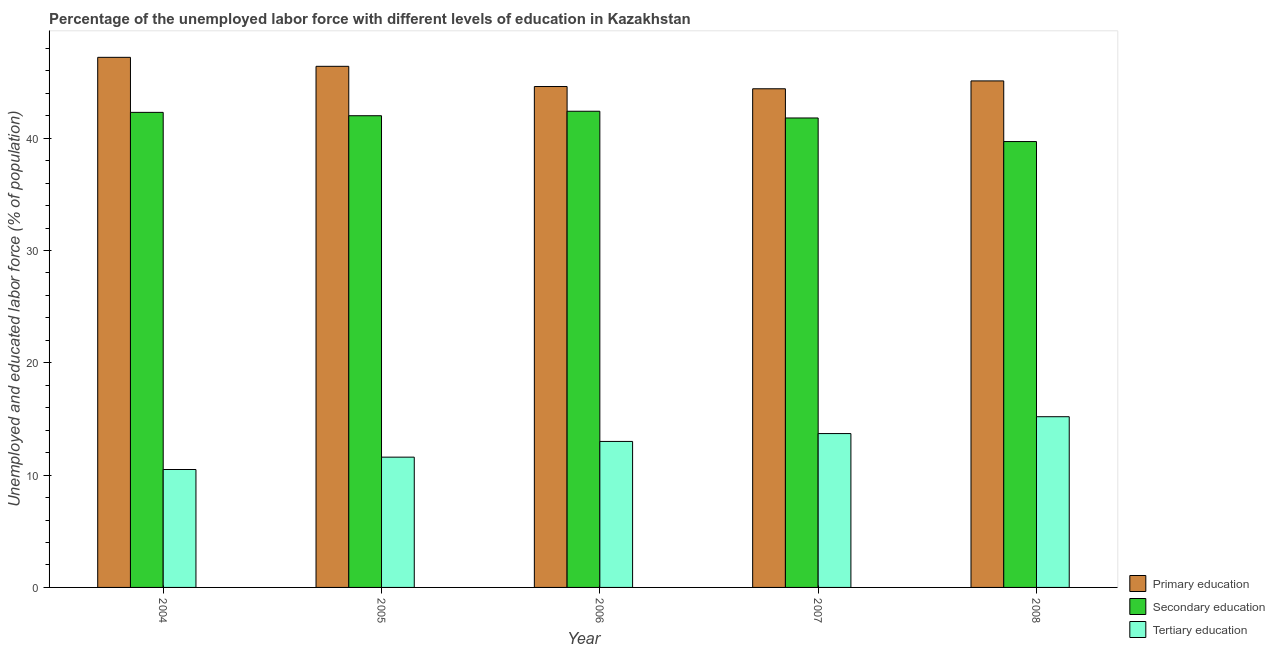Are the number of bars per tick equal to the number of legend labels?
Your answer should be very brief. Yes. How many bars are there on the 1st tick from the left?
Ensure brevity in your answer.  3. How many bars are there on the 5th tick from the right?
Ensure brevity in your answer.  3. What is the label of the 5th group of bars from the left?
Your response must be concise. 2008. What is the percentage of labor force who received primary education in 2005?
Offer a very short reply. 46.4. Across all years, what is the maximum percentage of labor force who received tertiary education?
Make the answer very short. 15.2. Across all years, what is the minimum percentage of labor force who received primary education?
Provide a succinct answer. 44.4. In which year was the percentage of labor force who received primary education minimum?
Your response must be concise. 2007. What is the total percentage of labor force who received tertiary education in the graph?
Make the answer very short. 64. What is the difference between the percentage of labor force who received secondary education in 2006 and that in 2007?
Provide a succinct answer. 0.6. What is the difference between the percentage of labor force who received secondary education in 2007 and the percentage of labor force who received primary education in 2008?
Offer a terse response. 2.1. What is the average percentage of labor force who received tertiary education per year?
Your answer should be compact. 12.8. In the year 2007, what is the difference between the percentage of labor force who received tertiary education and percentage of labor force who received primary education?
Your response must be concise. 0. What is the ratio of the percentage of labor force who received tertiary education in 2006 to that in 2008?
Provide a short and direct response. 0.86. Is the difference between the percentage of labor force who received primary education in 2005 and 2007 greater than the difference between the percentage of labor force who received secondary education in 2005 and 2007?
Your answer should be compact. No. What is the difference between the highest and the second highest percentage of labor force who received secondary education?
Give a very brief answer. 0.1. What is the difference between the highest and the lowest percentage of labor force who received primary education?
Offer a very short reply. 2.8. In how many years, is the percentage of labor force who received secondary education greater than the average percentage of labor force who received secondary education taken over all years?
Provide a succinct answer. 4. What does the 1st bar from the right in 2005 represents?
Your answer should be very brief. Tertiary education. Is it the case that in every year, the sum of the percentage of labor force who received primary education and percentage of labor force who received secondary education is greater than the percentage of labor force who received tertiary education?
Provide a succinct answer. Yes. Are all the bars in the graph horizontal?
Your response must be concise. No. What is the difference between two consecutive major ticks on the Y-axis?
Give a very brief answer. 10. Does the graph contain any zero values?
Your response must be concise. No. Does the graph contain grids?
Offer a terse response. No. What is the title of the graph?
Provide a succinct answer. Percentage of the unemployed labor force with different levels of education in Kazakhstan. Does "Private sector" appear as one of the legend labels in the graph?
Make the answer very short. No. What is the label or title of the Y-axis?
Your answer should be compact. Unemployed and educated labor force (% of population). What is the Unemployed and educated labor force (% of population) in Primary education in 2004?
Offer a very short reply. 47.2. What is the Unemployed and educated labor force (% of population) of Secondary education in 2004?
Ensure brevity in your answer.  42.3. What is the Unemployed and educated labor force (% of population) of Tertiary education in 2004?
Your answer should be compact. 10.5. What is the Unemployed and educated labor force (% of population) of Primary education in 2005?
Provide a succinct answer. 46.4. What is the Unemployed and educated labor force (% of population) of Tertiary education in 2005?
Your response must be concise. 11.6. What is the Unemployed and educated labor force (% of population) of Primary education in 2006?
Make the answer very short. 44.6. What is the Unemployed and educated labor force (% of population) in Secondary education in 2006?
Your response must be concise. 42.4. What is the Unemployed and educated labor force (% of population) of Primary education in 2007?
Offer a very short reply. 44.4. What is the Unemployed and educated labor force (% of population) in Secondary education in 2007?
Provide a succinct answer. 41.8. What is the Unemployed and educated labor force (% of population) in Tertiary education in 2007?
Give a very brief answer. 13.7. What is the Unemployed and educated labor force (% of population) in Primary education in 2008?
Give a very brief answer. 45.1. What is the Unemployed and educated labor force (% of population) of Secondary education in 2008?
Your response must be concise. 39.7. What is the Unemployed and educated labor force (% of population) of Tertiary education in 2008?
Your response must be concise. 15.2. Across all years, what is the maximum Unemployed and educated labor force (% of population) in Primary education?
Ensure brevity in your answer.  47.2. Across all years, what is the maximum Unemployed and educated labor force (% of population) in Secondary education?
Offer a terse response. 42.4. Across all years, what is the maximum Unemployed and educated labor force (% of population) in Tertiary education?
Your response must be concise. 15.2. Across all years, what is the minimum Unemployed and educated labor force (% of population) of Primary education?
Your answer should be very brief. 44.4. Across all years, what is the minimum Unemployed and educated labor force (% of population) in Secondary education?
Your answer should be compact. 39.7. Across all years, what is the minimum Unemployed and educated labor force (% of population) in Tertiary education?
Give a very brief answer. 10.5. What is the total Unemployed and educated labor force (% of population) of Primary education in the graph?
Offer a terse response. 227.7. What is the total Unemployed and educated labor force (% of population) in Secondary education in the graph?
Offer a terse response. 208.2. What is the difference between the Unemployed and educated labor force (% of population) of Secondary education in 2004 and that in 2006?
Provide a short and direct response. -0.1. What is the difference between the Unemployed and educated labor force (% of population) in Tertiary education in 2004 and that in 2007?
Your answer should be compact. -3.2. What is the difference between the Unemployed and educated labor force (% of population) of Primary education in 2004 and that in 2008?
Your response must be concise. 2.1. What is the difference between the Unemployed and educated labor force (% of population) in Secondary education in 2005 and that in 2006?
Keep it short and to the point. -0.4. What is the difference between the Unemployed and educated labor force (% of population) of Tertiary education in 2005 and that in 2006?
Ensure brevity in your answer.  -1.4. What is the difference between the Unemployed and educated labor force (% of population) of Secondary education in 2005 and that in 2007?
Provide a succinct answer. 0.2. What is the difference between the Unemployed and educated labor force (% of population) of Tertiary education in 2005 and that in 2007?
Make the answer very short. -2.1. What is the difference between the Unemployed and educated labor force (% of population) in Primary education in 2005 and that in 2008?
Give a very brief answer. 1.3. What is the difference between the Unemployed and educated labor force (% of population) of Tertiary education in 2005 and that in 2008?
Offer a very short reply. -3.6. What is the difference between the Unemployed and educated labor force (% of population) in Primary education in 2006 and that in 2008?
Your answer should be very brief. -0.5. What is the difference between the Unemployed and educated labor force (% of population) in Secondary education in 2006 and that in 2008?
Give a very brief answer. 2.7. What is the difference between the Unemployed and educated labor force (% of population) in Tertiary education in 2007 and that in 2008?
Keep it short and to the point. -1.5. What is the difference between the Unemployed and educated labor force (% of population) in Primary education in 2004 and the Unemployed and educated labor force (% of population) in Secondary education in 2005?
Ensure brevity in your answer.  5.2. What is the difference between the Unemployed and educated labor force (% of population) of Primary education in 2004 and the Unemployed and educated labor force (% of population) of Tertiary education in 2005?
Make the answer very short. 35.6. What is the difference between the Unemployed and educated labor force (% of population) of Secondary education in 2004 and the Unemployed and educated labor force (% of population) of Tertiary education in 2005?
Give a very brief answer. 30.7. What is the difference between the Unemployed and educated labor force (% of population) of Primary education in 2004 and the Unemployed and educated labor force (% of population) of Tertiary education in 2006?
Provide a short and direct response. 34.2. What is the difference between the Unemployed and educated labor force (% of population) of Secondary education in 2004 and the Unemployed and educated labor force (% of population) of Tertiary education in 2006?
Make the answer very short. 29.3. What is the difference between the Unemployed and educated labor force (% of population) in Primary education in 2004 and the Unemployed and educated labor force (% of population) in Secondary education in 2007?
Offer a very short reply. 5.4. What is the difference between the Unemployed and educated labor force (% of population) of Primary education in 2004 and the Unemployed and educated labor force (% of population) of Tertiary education in 2007?
Give a very brief answer. 33.5. What is the difference between the Unemployed and educated labor force (% of population) in Secondary education in 2004 and the Unemployed and educated labor force (% of population) in Tertiary education in 2007?
Make the answer very short. 28.6. What is the difference between the Unemployed and educated labor force (% of population) of Primary education in 2004 and the Unemployed and educated labor force (% of population) of Tertiary education in 2008?
Make the answer very short. 32. What is the difference between the Unemployed and educated labor force (% of population) of Secondary education in 2004 and the Unemployed and educated labor force (% of population) of Tertiary education in 2008?
Provide a succinct answer. 27.1. What is the difference between the Unemployed and educated labor force (% of population) of Primary education in 2005 and the Unemployed and educated labor force (% of population) of Tertiary education in 2006?
Your answer should be compact. 33.4. What is the difference between the Unemployed and educated labor force (% of population) in Primary education in 2005 and the Unemployed and educated labor force (% of population) in Tertiary education in 2007?
Your answer should be compact. 32.7. What is the difference between the Unemployed and educated labor force (% of population) of Secondary education in 2005 and the Unemployed and educated labor force (% of population) of Tertiary education in 2007?
Offer a terse response. 28.3. What is the difference between the Unemployed and educated labor force (% of population) of Primary education in 2005 and the Unemployed and educated labor force (% of population) of Secondary education in 2008?
Your response must be concise. 6.7. What is the difference between the Unemployed and educated labor force (% of population) of Primary education in 2005 and the Unemployed and educated labor force (% of population) of Tertiary education in 2008?
Your answer should be compact. 31.2. What is the difference between the Unemployed and educated labor force (% of population) of Secondary education in 2005 and the Unemployed and educated labor force (% of population) of Tertiary education in 2008?
Offer a terse response. 26.8. What is the difference between the Unemployed and educated labor force (% of population) in Primary education in 2006 and the Unemployed and educated labor force (% of population) in Tertiary education in 2007?
Your answer should be very brief. 30.9. What is the difference between the Unemployed and educated labor force (% of population) in Secondary education in 2006 and the Unemployed and educated labor force (% of population) in Tertiary education in 2007?
Make the answer very short. 28.7. What is the difference between the Unemployed and educated labor force (% of population) in Primary education in 2006 and the Unemployed and educated labor force (% of population) in Tertiary education in 2008?
Make the answer very short. 29.4. What is the difference between the Unemployed and educated labor force (% of population) of Secondary education in 2006 and the Unemployed and educated labor force (% of population) of Tertiary education in 2008?
Your answer should be compact. 27.2. What is the difference between the Unemployed and educated labor force (% of population) of Primary education in 2007 and the Unemployed and educated labor force (% of population) of Tertiary education in 2008?
Your answer should be compact. 29.2. What is the difference between the Unemployed and educated labor force (% of population) in Secondary education in 2007 and the Unemployed and educated labor force (% of population) in Tertiary education in 2008?
Keep it short and to the point. 26.6. What is the average Unemployed and educated labor force (% of population) in Primary education per year?
Offer a terse response. 45.54. What is the average Unemployed and educated labor force (% of population) of Secondary education per year?
Provide a short and direct response. 41.64. What is the average Unemployed and educated labor force (% of population) of Tertiary education per year?
Offer a very short reply. 12.8. In the year 2004, what is the difference between the Unemployed and educated labor force (% of population) in Primary education and Unemployed and educated labor force (% of population) in Secondary education?
Provide a short and direct response. 4.9. In the year 2004, what is the difference between the Unemployed and educated labor force (% of population) of Primary education and Unemployed and educated labor force (% of population) of Tertiary education?
Keep it short and to the point. 36.7. In the year 2004, what is the difference between the Unemployed and educated labor force (% of population) in Secondary education and Unemployed and educated labor force (% of population) in Tertiary education?
Make the answer very short. 31.8. In the year 2005, what is the difference between the Unemployed and educated labor force (% of population) of Primary education and Unemployed and educated labor force (% of population) of Secondary education?
Offer a very short reply. 4.4. In the year 2005, what is the difference between the Unemployed and educated labor force (% of population) of Primary education and Unemployed and educated labor force (% of population) of Tertiary education?
Your answer should be compact. 34.8. In the year 2005, what is the difference between the Unemployed and educated labor force (% of population) in Secondary education and Unemployed and educated labor force (% of population) in Tertiary education?
Make the answer very short. 30.4. In the year 2006, what is the difference between the Unemployed and educated labor force (% of population) of Primary education and Unemployed and educated labor force (% of population) of Secondary education?
Keep it short and to the point. 2.2. In the year 2006, what is the difference between the Unemployed and educated labor force (% of population) in Primary education and Unemployed and educated labor force (% of population) in Tertiary education?
Keep it short and to the point. 31.6. In the year 2006, what is the difference between the Unemployed and educated labor force (% of population) in Secondary education and Unemployed and educated labor force (% of population) in Tertiary education?
Provide a succinct answer. 29.4. In the year 2007, what is the difference between the Unemployed and educated labor force (% of population) of Primary education and Unemployed and educated labor force (% of population) of Secondary education?
Give a very brief answer. 2.6. In the year 2007, what is the difference between the Unemployed and educated labor force (% of population) in Primary education and Unemployed and educated labor force (% of population) in Tertiary education?
Provide a short and direct response. 30.7. In the year 2007, what is the difference between the Unemployed and educated labor force (% of population) in Secondary education and Unemployed and educated labor force (% of population) in Tertiary education?
Offer a terse response. 28.1. In the year 2008, what is the difference between the Unemployed and educated labor force (% of population) of Primary education and Unemployed and educated labor force (% of population) of Secondary education?
Provide a succinct answer. 5.4. In the year 2008, what is the difference between the Unemployed and educated labor force (% of population) in Primary education and Unemployed and educated labor force (% of population) in Tertiary education?
Provide a short and direct response. 29.9. What is the ratio of the Unemployed and educated labor force (% of population) of Primary education in 2004 to that in 2005?
Offer a very short reply. 1.02. What is the ratio of the Unemployed and educated labor force (% of population) of Secondary education in 2004 to that in 2005?
Give a very brief answer. 1.01. What is the ratio of the Unemployed and educated labor force (% of population) of Tertiary education in 2004 to that in 2005?
Your answer should be very brief. 0.91. What is the ratio of the Unemployed and educated labor force (% of population) in Primary education in 2004 to that in 2006?
Keep it short and to the point. 1.06. What is the ratio of the Unemployed and educated labor force (% of population) in Secondary education in 2004 to that in 2006?
Give a very brief answer. 1. What is the ratio of the Unemployed and educated labor force (% of population) of Tertiary education in 2004 to that in 2006?
Offer a very short reply. 0.81. What is the ratio of the Unemployed and educated labor force (% of population) of Primary education in 2004 to that in 2007?
Keep it short and to the point. 1.06. What is the ratio of the Unemployed and educated labor force (% of population) in Tertiary education in 2004 to that in 2007?
Provide a short and direct response. 0.77. What is the ratio of the Unemployed and educated labor force (% of population) of Primary education in 2004 to that in 2008?
Give a very brief answer. 1.05. What is the ratio of the Unemployed and educated labor force (% of population) in Secondary education in 2004 to that in 2008?
Ensure brevity in your answer.  1.07. What is the ratio of the Unemployed and educated labor force (% of population) in Tertiary education in 2004 to that in 2008?
Your response must be concise. 0.69. What is the ratio of the Unemployed and educated labor force (% of population) in Primary education in 2005 to that in 2006?
Your answer should be compact. 1.04. What is the ratio of the Unemployed and educated labor force (% of population) in Secondary education in 2005 to that in 2006?
Your answer should be compact. 0.99. What is the ratio of the Unemployed and educated labor force (% of population) of Tertiary education in 2005 to that in 2006?
Give a very brief answer. 0.89. What is the ratio of the Unemployed and educated labor force (% of population) in Primary education in 2005 to that in 2007?
Offer a terse response. 1.04. What is the ratio of the Unemployed and educated labor force (% of population) of Tertiary education in 2005 to that in 2007?
Make the answer very short. 0.85. What is the ratio of the Unemployed and educated labor force (% of population) of Primary education in 2005 to that in 2008?
Make the answer very short. 1.03. What is the ratio of the Unemployed and educated labor force (% of population) of Secondary education in 2005 to that in 2008?
Your answer should be compact. 1.06. What is the ratio of the Unemployed and educated labor force (% of population) of Tertiary education in 2005 to that in 2008?
Your answer should be very brief. 0.76. What is the ratio of the Unemployed and educated labor force (% of population) in Primary education in 2006 to that in 2007?
Keep it short and to the point. 1. What is the ratio of the Unemployed and educated labor force (% of population) in Secondary education in 2006 to that in 2007?
Provide a succinct answer. 1.01. What is the ratio of the Unemployed and educated labor force (% of population) of Tertiary education in 2006 to that in 2007?
Make the answer very short. 0.95. What is the ratio of the Unemployed and educated labor force (% of population) in Primary education in 2006 to that in 2008?
Ensure brevity in your answer.  0.99. What is the ratio of the Unemployed and educated labor force (% of population) in Secondary education in 2006 to that in 2008?
Provide a succinct answer. 1.07. What is the ratio of the Unemployed and educated labor force (% of population) in Tertiary education in 2006 to that in 2008?
Offer a terse response. 0.86. What is the ratio of the Unemployed and educated labor force (% of population) in Primary education in 2007 to that in 2008?
Make the answer very short. 0.98. What is the ratio of the Unemployed and educated labor force (% of population) in Secondary education in 2007 to that in 2008?
Offer a terse response. 1.05. What is the ratio of the Unemployed and educated labor force (% of population) in Tertiary education in 2007 to that in 2008?
Keep it short and to the point. 0.9. What is the difference between the highest and the second highest Unemployed and educated labor force (% of population) of Secondary education?
Make the answer very short. 0.1. What is the difference between the highest and the second highest Unemployed and educated labor force (% of population) in Tertiary education?
Your answer should be compact. 1.5. What is the difference between the highest and the lowest Unemployed and educated labor force (% of population) of Secondary education?
Your response must be concise. 2.7. 